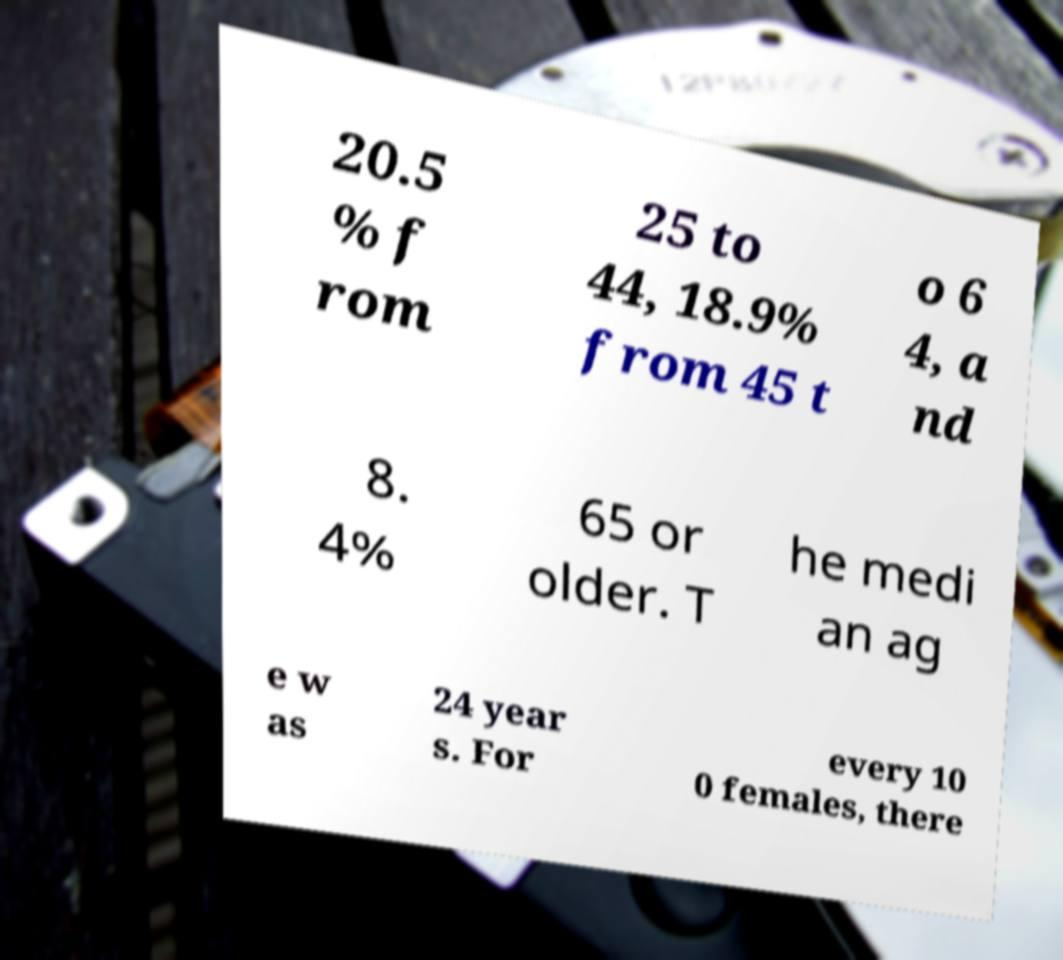I need the written content from this picture converted into text. Can you do that? 20.5 % f rom 25 to 44, 18.9% from 45 t o 6 4, a nd 8. 4% 65 or older. T he medi an ag e w as 24 year s. For every 10 0 females, there 